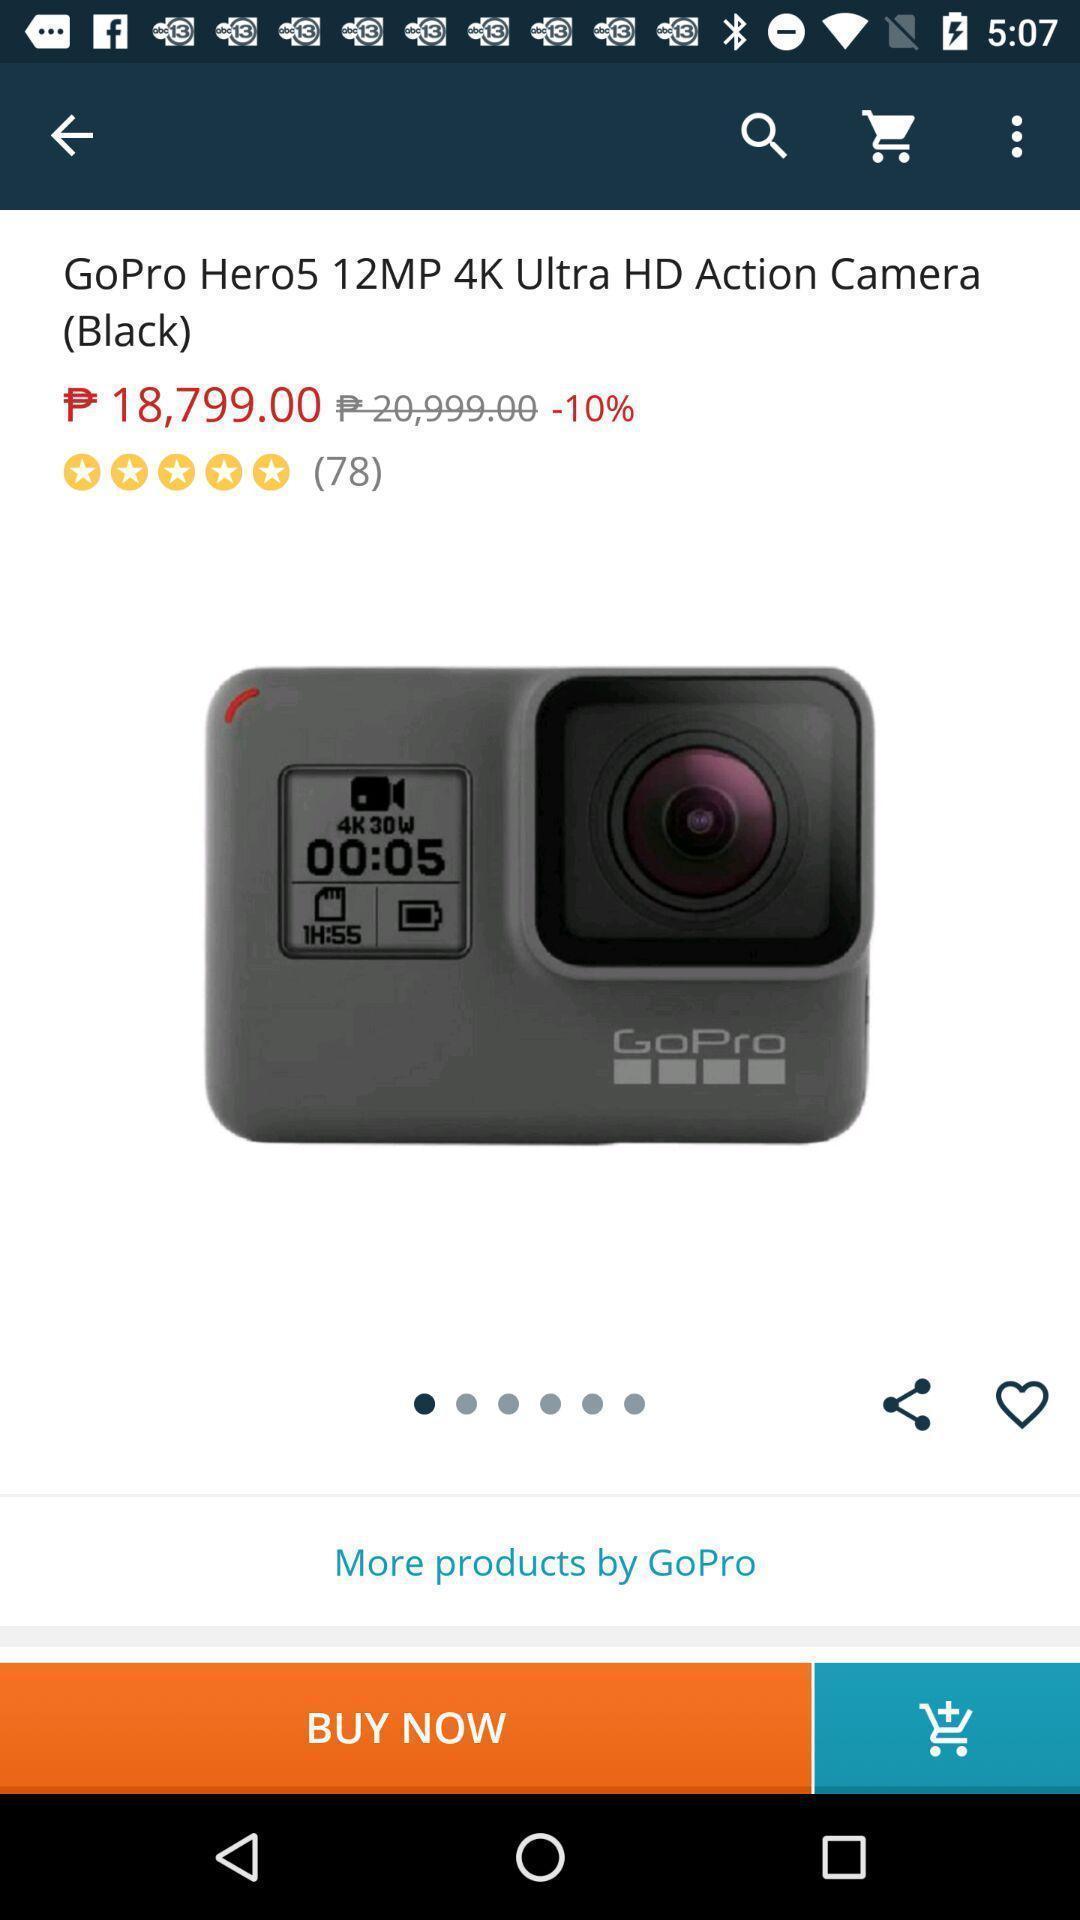Summarize the information in this screenshot. Page showing a product on a shopping app. 